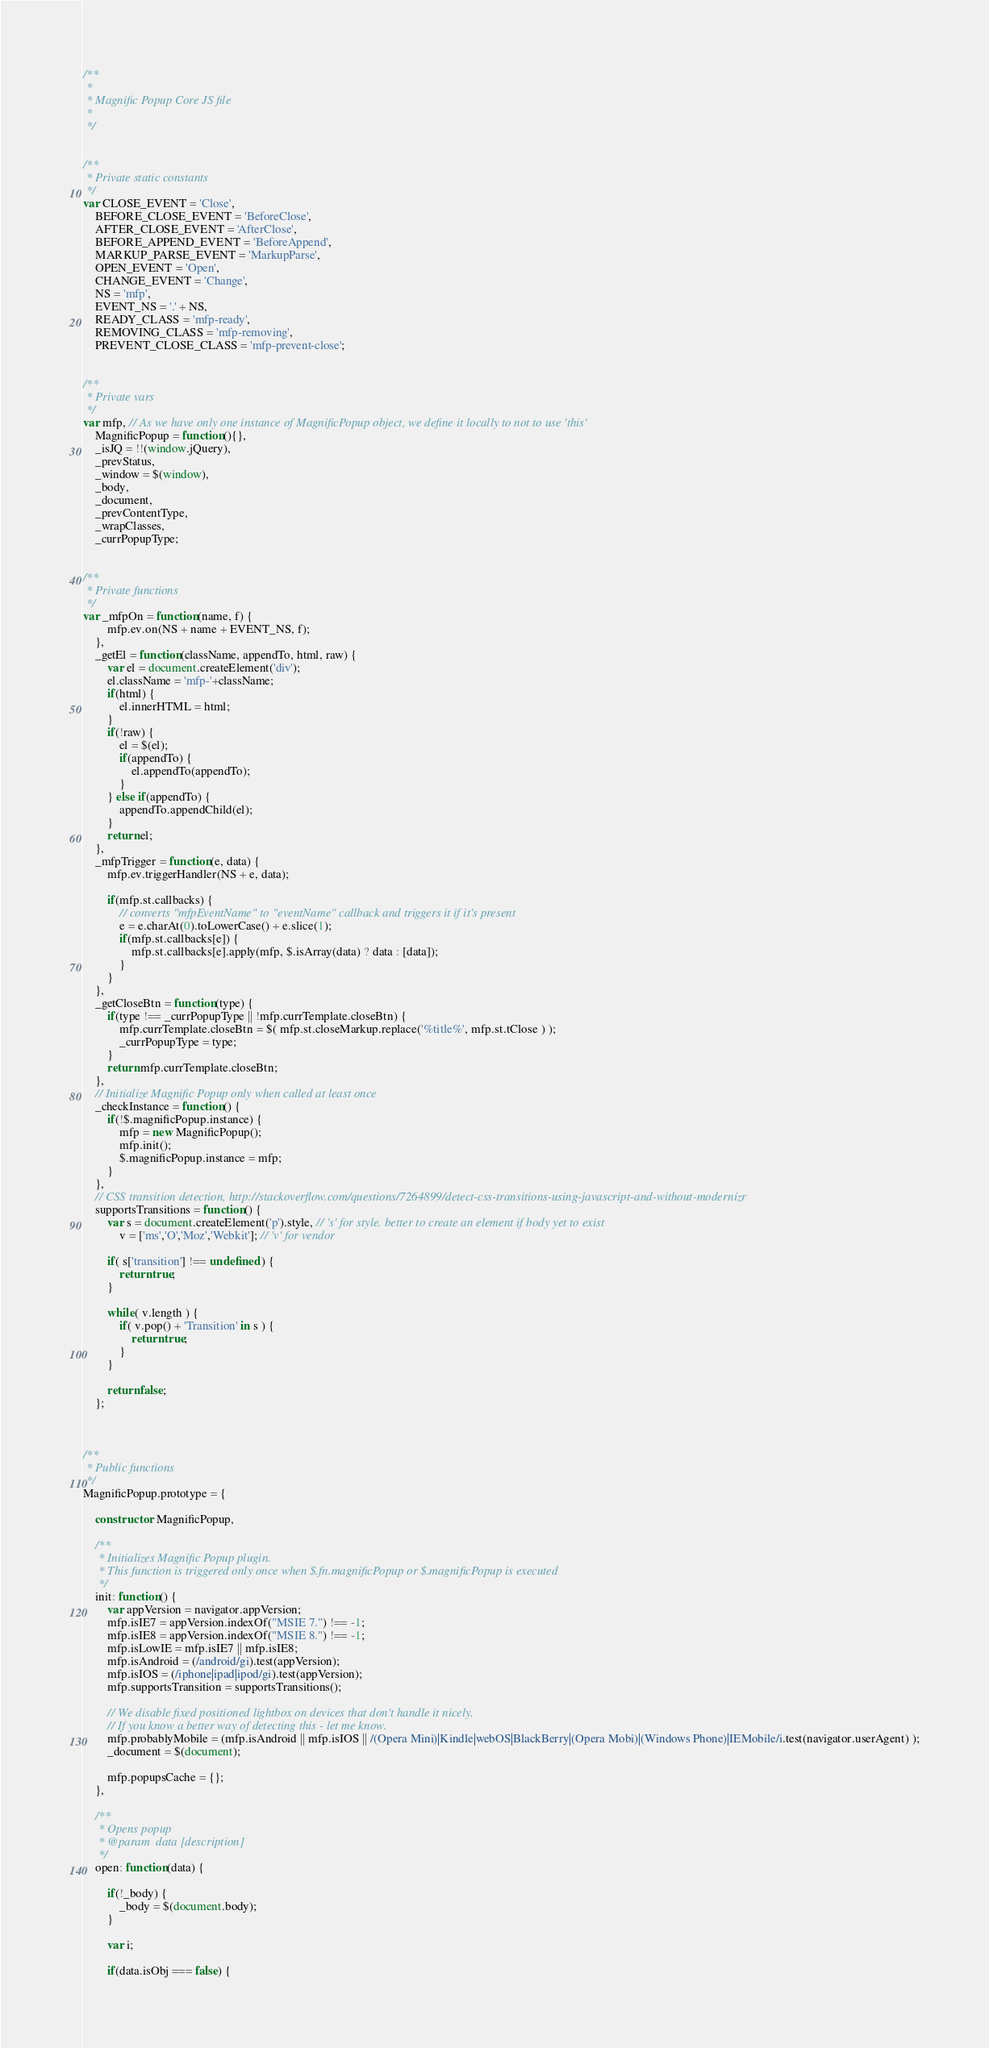<code> <loc_0><loc_0><loc_500><loc_500><_JavaScript_>/**
 *
 * Magnific Popup Core JS file
 *
 */


/**
 * Private static constants
 */
var CLOSE_EVENT = 'Close',
	BEFORE_CLOSE_EVENT = 'BeforeClose',
	AFTER_CLOSE_EVENT = 'AfterClose',
	BEFORE_APPEND_EVENT = 'BeforeAppend',
	MARKUP_PARSE_EVENT = 'MarkupParse',
	OPEN_EVENT = 'Open',
	CHANGE_EVENT = 'Change',
	NS = 'mfp',
	EVENT_NS = '.' + NS,
	READY_CLASS = 'mfp-ready',
	REMOVING_CLASS = 'mfp-removing',
	PREVENT_CLOSE_CLASS = 'mfp-prevent-close';


/**
 * Private vars
 */
var mfp, // As we have only one instance of MagnificPopup object, we define it locally to not to use 'this'
	MagnificPopup = function(){},
	_isJQ = !!(window.jQuery),
	_prevStatus,
	_window = $(window),
	_body,
	_document,
	_prevContentType,
	_wrapClasses,
	_currPopupType;


/**
 * Private functions
 */
var _mfpOn = function(name, f) {
		mfp.ev.on(NS + name + EVENT_NS, f);
	},
	_getEl = function(className, appendTo, html, raw) {
		var el = document.createElement('div');
		el.className = 'mfp-'+className;
		if(html) {
			el.innerHTML = html;
		}
		if(!raw) {
			el = $(el);
			if(appendTo) {
				el.appendTo(appendTo);
			}
		} else if(appendTo) {
			appendTo.appendChild(el);
		}
		return el;
	},
	_mfpTrigger = function(e, data) {
		mfp.ev.triggerHandler(NS + e, data);

		if(mfp.st.callbacks) {
			// converts "mfpEventName" to "eventName" callback and triggers it if it's present
			e = e.charAt(0).toLowerCase() + e.slice(1);
			if(mfp.st.callbacks[e]) {
				mfp.st.callbacks[e].apply(mfp, $.isArray(data) ? data : [data]);
			}
		}
	},
	_getCloseBtn = function(type) {
		if(type !== _currPopupType || !mfp.currTemplate.closeBtn) {
			mfp.currTemplate.closeBtn = $( mfp.st.closeMarkup.replace('%title%', mfp.st.tClose ) );
			_currPopupType = type;
		}
		return mfp.currTemplate.closeBtn;
	},
	// Initialize Magnific Popup only when called at least once
	_checkInstance = function() {
		if(!$.magnificPopup.instance) {
			mfp = new MagnificPopup();
			mfp.init();
			$.magnificPopup.instance = mfp;
		}
	},
	// CSS transition detection, http://stackoverflow.com/questions/7264899/detect-css-transitions-using-javascript-and-without-modernizr
	supportsTransitions = function() {
		var s = document.createElement('p').style, // 's' for style. better to create an element if body yet to exist
			v = ['ms','O','Moz','Webkit']; // 'v' for vendor

		if( s['transition'] !== undefined ) {
			return true;
		}

		while( v.length ) {
			if( v.pop() + 'Transition' in s ) {
				return true;
			}
		}

		return false;
	};



/**
 * Public functions
 */
MagnificPopup.prototype = {

	constructor: MagnificPopup,

	/**
	 * Initializes Magnific Popup plugin.
	 * This function is triggered only once when $.fn.magnificPopup or $.magnificPopup is executed
	 */
	init: function() {
		var appVersion = navigator.appVersion;
		mfp.isIE7 = appVersion.indexOf("MSIE 7.") !== -1;
		mfp.isIE8 = appVersion.indexOf("MSIE 8.") !== -1;
		mfp.isLowIE = mfp.isIE7 || mfp.isIE8;
		mfp.isAndroid = (/android/gi).test(appVersion);
		mfp.isIOS = (/iphone|ipad|ipod/gi).test(appVersion);
		mfp.supportsTransition = supportsTransitions();

		// We disable fixed positioned lightbox on devices that don't handle it nicely.
		// If you know a better way of detecting this - let me know.
		mfp.probablyMobile = (mfp.isAndroid || mfp.isIOS || /(Opera Mini)|Kindle|webOS|BlackBerry|(Opera Mobi)|(Windows Phone)|IEMobile/i.test(navigator.userAgent) );
		_document = $(document);

		mfp.popupsCache = {};
	},

	/**
	 * Opens popup
	 * @param  data [description]
	 */
	open: function(data) {

		if(!_body) {
			_body = $(document.body);
		}

		var i;

		if(data.isObj === false) {</code> 